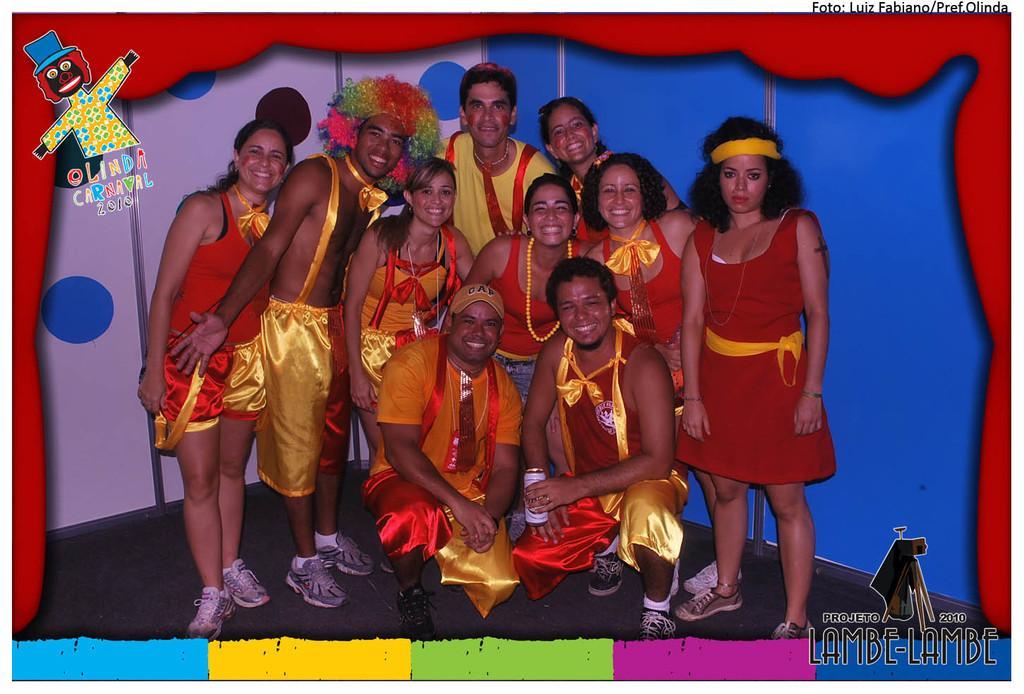How would you summarize this image in a sentence or two? In the image there are few people standing and there are two men in sitting position. They are wearing costumes. Behind them there is a blue wall and also there is a white wall with blue circles. In the top left corner of the image there is a toy. And in the bottom right corner of the image there is a name and a logo. There are different colors of borders. 